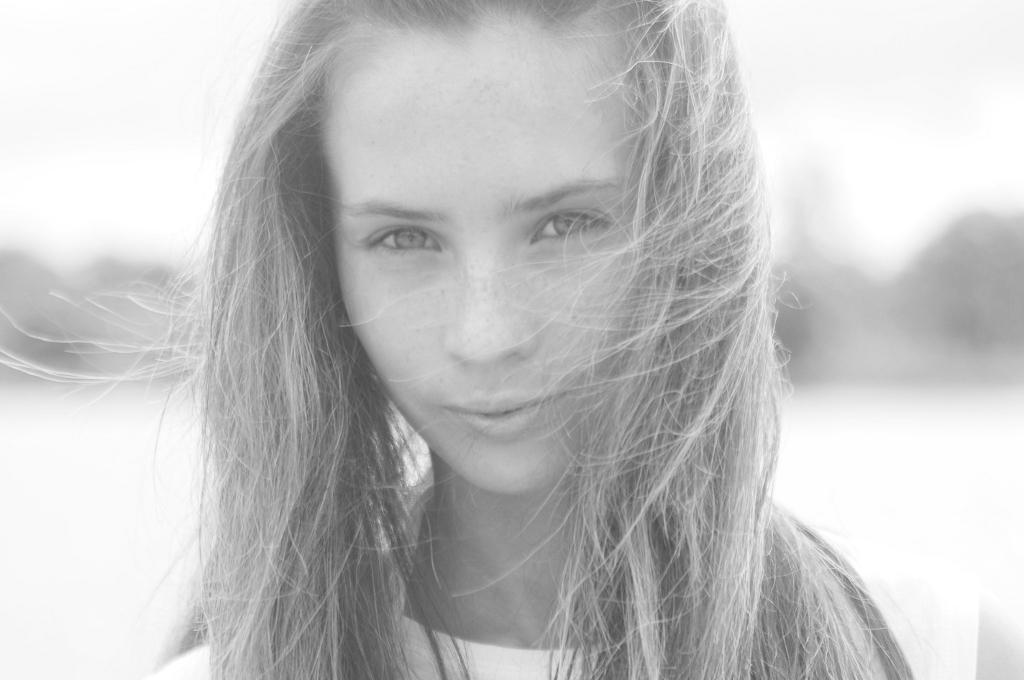What is the main subject of the image? The main subject of the image is a woman. Can you describe the background of the image? The background of the image has a blurred view. How many legs can be seen on the horses in the image? There are no horses present in the image, so it is not possible to determine the number of legs. 